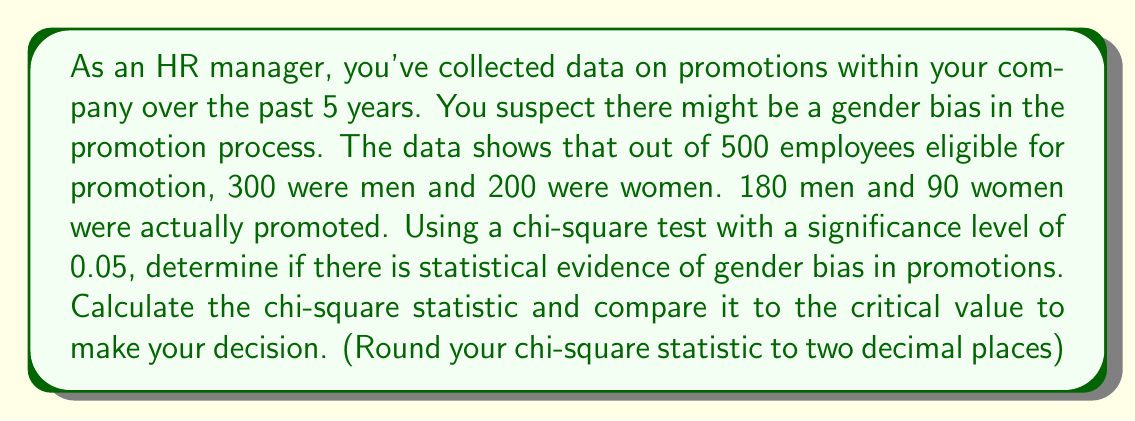Give your solution to this math problem. To analyze this data using a chi-square test, we'll follow these steps:

1) First, let's set up our observed and expected frequencies:

   Observed frequencies:
   Men promoted: 180, Men not promoted: 120
   Women promoted: 90, Women not promoted: 110

   Expected frequencies (if no bias):
   Men promoted: 300 * (270/500) = 162
   Men not promoted: 300 * (230/500) = 138
   Women promoted: 200 * (270/500) = 108
   Women not promoted: 200 * (230/500) = 92

2) The chi-square statistic is calculated using the formula:

   $$\chi^2 = \sum \frac{(O - E)^2}{E}$$

   Where O is the observed frequency and E is the expected frequency.

3) Let's calculate each term:

   $$(180 - 162)^2 / 162 = 2.00$$
   $$(120 - 138)^2 / 138 = 2.35$$
   $$(90 - 108)^2 / 108 = 3.00$$
   $$(110 - 92)^2 / 92 = 3.52$$

4) Sum these terms:

   $$\chi^2 = 2.00 + 2.35 + 3.00 + 3.52 = 10.87$$

5) The degrees of freedom for this test is (rows - 1) * (columns - 1) = 1

6) The critical value for a chi-square distribution with 1 degree of freedom at a 0.05 significance level is 3.841.

7) Since our calculated chi-square value (10.87) is greater than the critical value (3.841), we reject the null hypothesis.
Answer: The chi-square statistic is 10.87, which is greater than the critical value of 3.841. Therefore, there is statistical evidence of gender bias in promotions at the 0.05 significance level. 